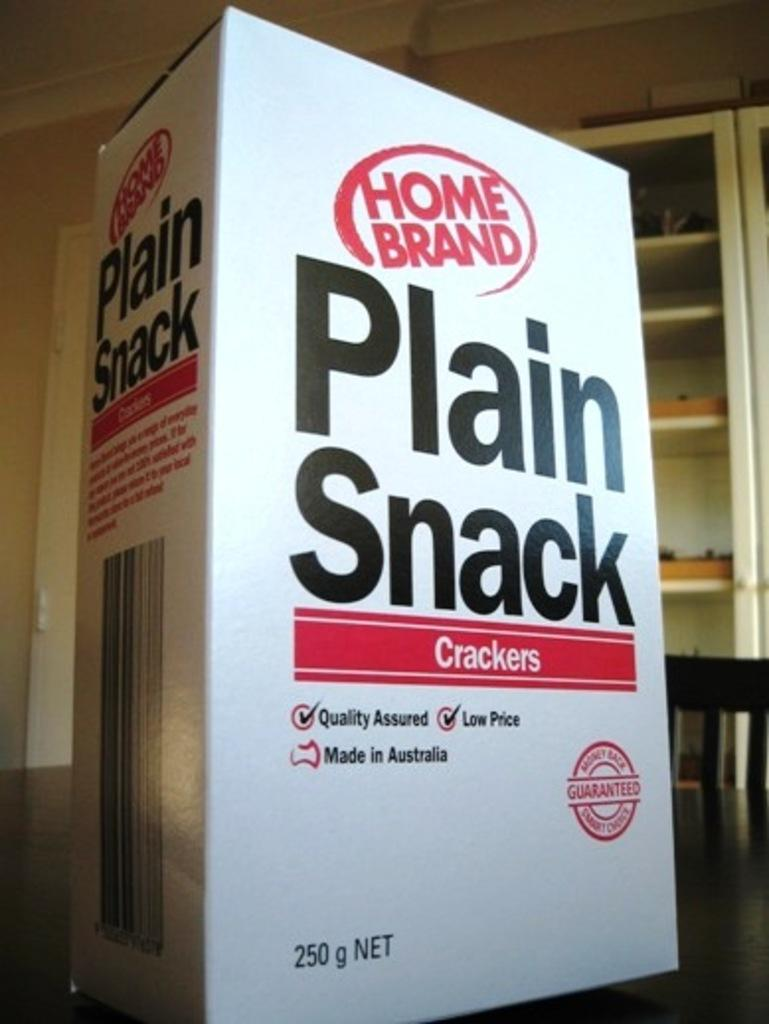Provide a one-sentence caption for the provided image. A box of Plain Snack Crackers on a table. 